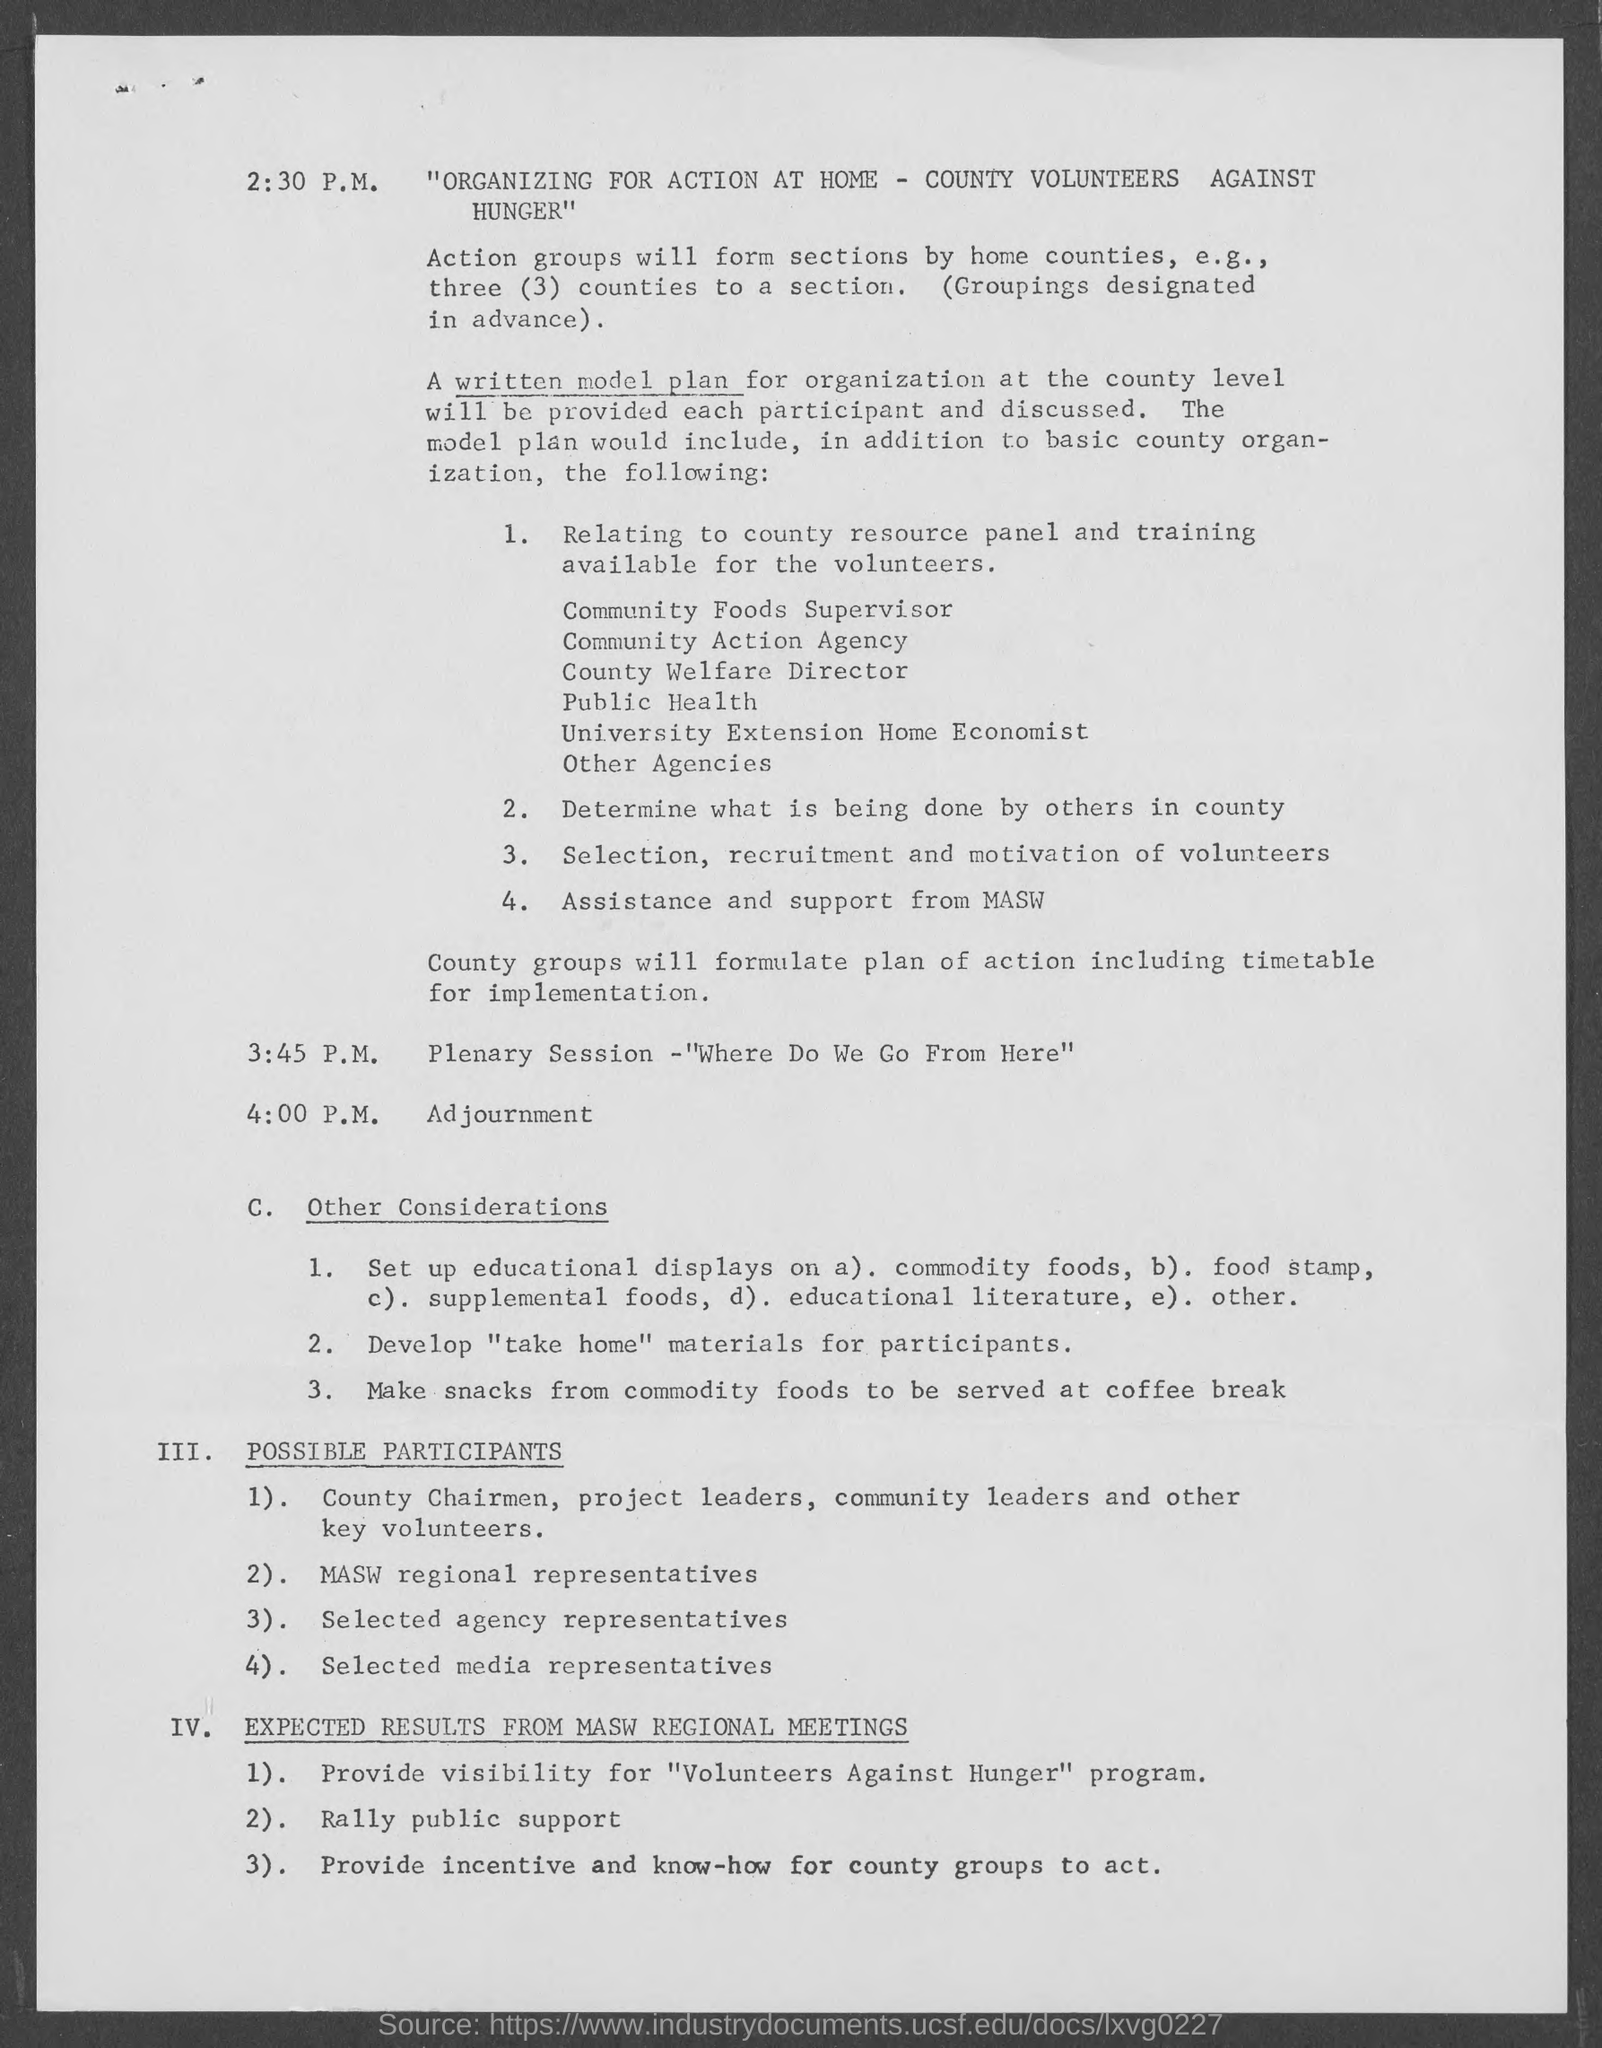When is the plenary session?
Make the answer very short. 3:45 p.m. When is the Adjournment?
Provide a succinct answer. 4:00 p.m. 